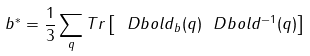<formula> <loc_0><loc_0><loc_500><loc_500>b ^ { * } = \frac { 1 } { 3 } \sum _ { q } T r \left [ \ D b o l d _ { b } ( q ) \ D b o l d ^ { - 1 } ( q ) \right ]</formula> 